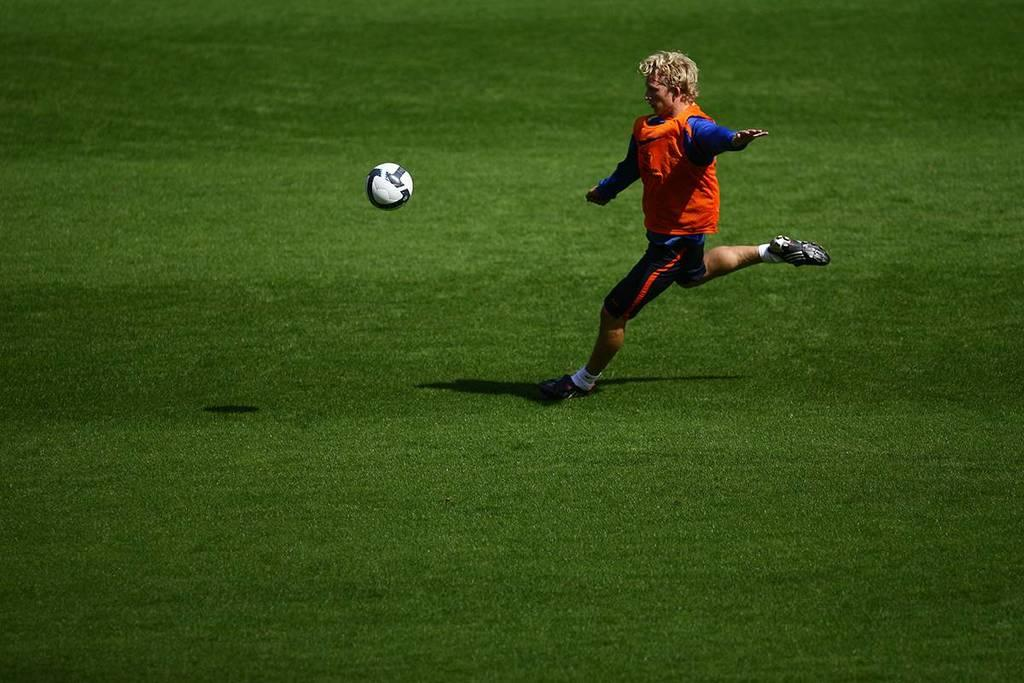What is the person in the image doing? The person is playing football. How is the person interacting with the football? The person is running on the ground and the football is flying in the air. What type of dinner is being served on the football field in the image? There is no dinner or any food being served in the image; it features a person playing football. What role does the coal play in the person's football game in the image? There is no coal present in the image, so it does not play any role in the person's football game. 